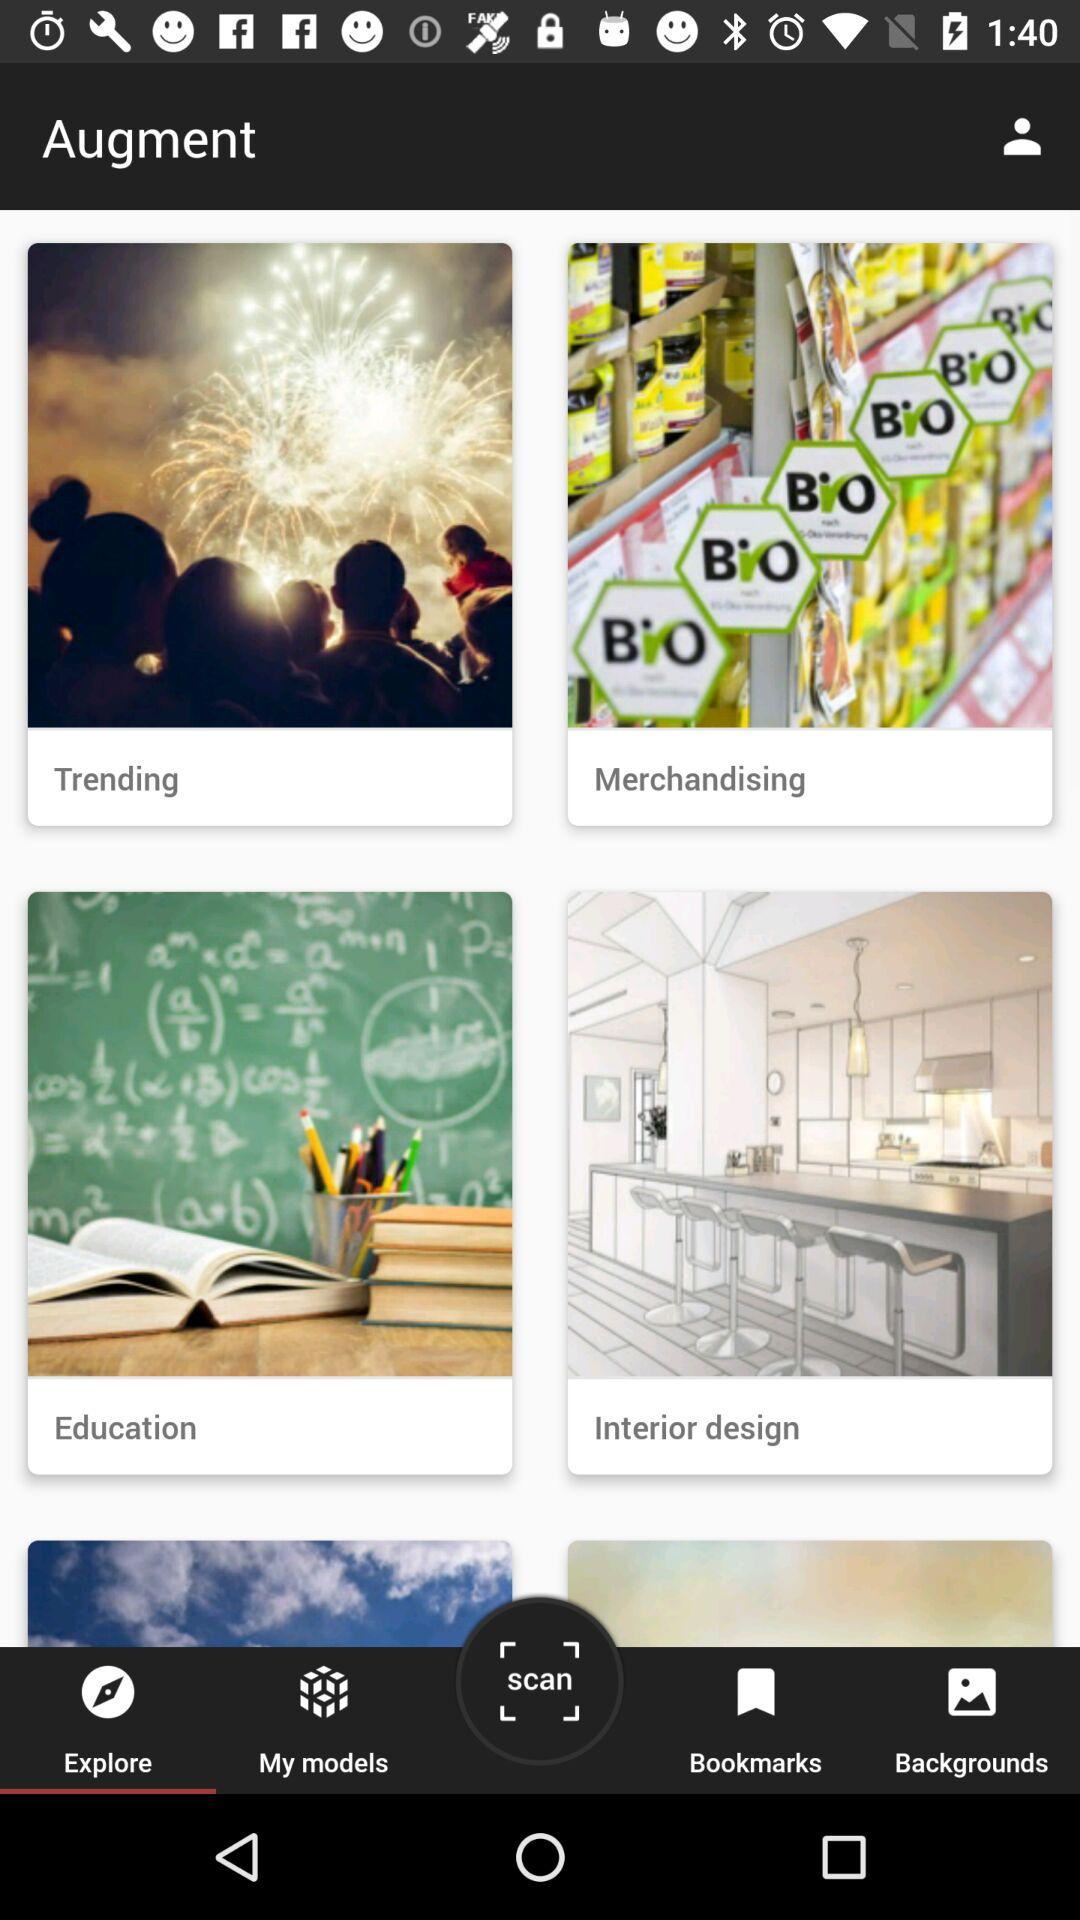Which tab has been selected? The tab that has been selected is "Explore". 